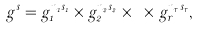Convert formula to latex. <formula><loc_0><loc_0><loc_500><loc_500>g ^ { s } = g _ { 1 } ^ { n _ { 1 } s _ { 1 } } \times g _ { 2 } ^ { n _ { 2 } s _ { 2 } } \times \dots \times g _ { r } ^ { n _ { r } s _ { r } } ,</formula> 